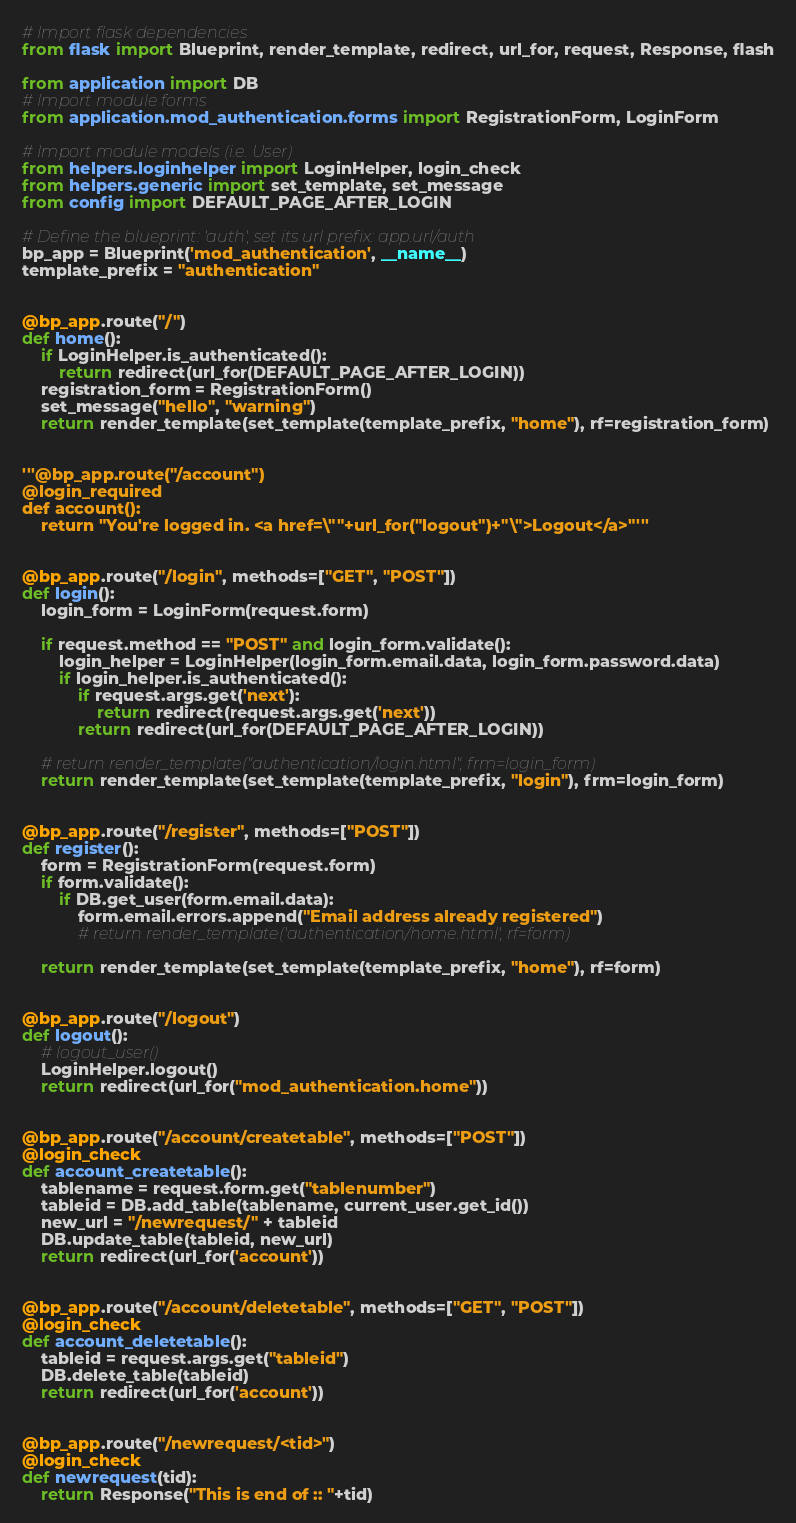<code> <loc_0><loc_0><loc_500><loc_500><_Python_># Import flask dependencies
from flask import Blueprint, render_template, redirect, url_for, request, Response, flash

from application import DB
# Import module forms
from application.mod_authentication.forms import RegistrationForm, LoginForm

# Import module models (i.e. User)
from helpers.loginhelper import LoginHelper, login_check
from helpers.generic import set_template, set_message
from config import DEFAULT_PAGE_AFTER_LOGIN

# Define the blueprint: 'auth', set its url prefix: app.url/auth
bp_app = Blueprint('mod_authentication', __name__)
template_prefix = "authentication"


@bp_app.route("/")
def home():
    if LoginHelper.is_authenticated():
        return redirect(url_for(DEFAULT_PAGE_AFTER_LOGIN))
    registration_form = RegistrationForm()
    set_message("hello", "warning")
    return render_template(set_template(template_prefix, "home"), rf=registration_form)


'''@bp_app.route("/account")
@login_required
def account():
    return "You're logged in. <a href=\""+url_for("logout")+"\">Logout</a>"'''


@bp_app.route("/login", methods=["GET", "POST"])
def login():
    login_form = LoginForm(request.form)

    if request.method == "POST" and login_form.validate():
        login_helper = LoginHelper(login_form.email.data, login_form.password.data)
        if login_helper.is_authenticated():
            if request.args.get('next'):
                return redirect(request.args.get('next'))
            return redirect(url_for(DEFAULT_PAGE_AFTER_LOGIN))

    # return render_template("authentication/login.html", frm=login_form)
    return render_template(set_template(template_prefix, "login"), frm=login_form)


@bp_app.route("/register", methods=["POST"])
def register():
    form = RegistrationForm(request.form)
    if form.validate():
        if DB.get_user(form.email.data):
            form.email.errors.append("Email address already registered")
            # return render_template('authentication/home.html', rf=form)

    return render_template(set_template(template_prefix, "home"), rf=form)


@bp_app.route("/logout")
def logout():
    # logout_user()
    LoginHelper.logout()
    return redirect(url_for("mod_authentication.home"))


@bp_app.route("/account/createtable", methods=["POST"])
@login_check
def account_createtable():
    tablename = request.form.get("tablenumber")
    tableid = DB.add_table(tablename, current_user.get_id())
    new_url = "/newrequest/" + tableid
    DB.update_table(tableid, new_url)
    return redirect(url_for('account'))


@bp_app.route("/account/deletetable", methods=["GET", "POST"])
@login_check
def account_deletetable():
    tableid = request.args.get("tableid")
    DB.delete_table(tableid)
    return redirect(url_for('account'))


@bp_app.route("/newrequest/<tid>")
@login_check
def newrequest(tid):
    return Response("This is end of :: "+tid)
</code> 